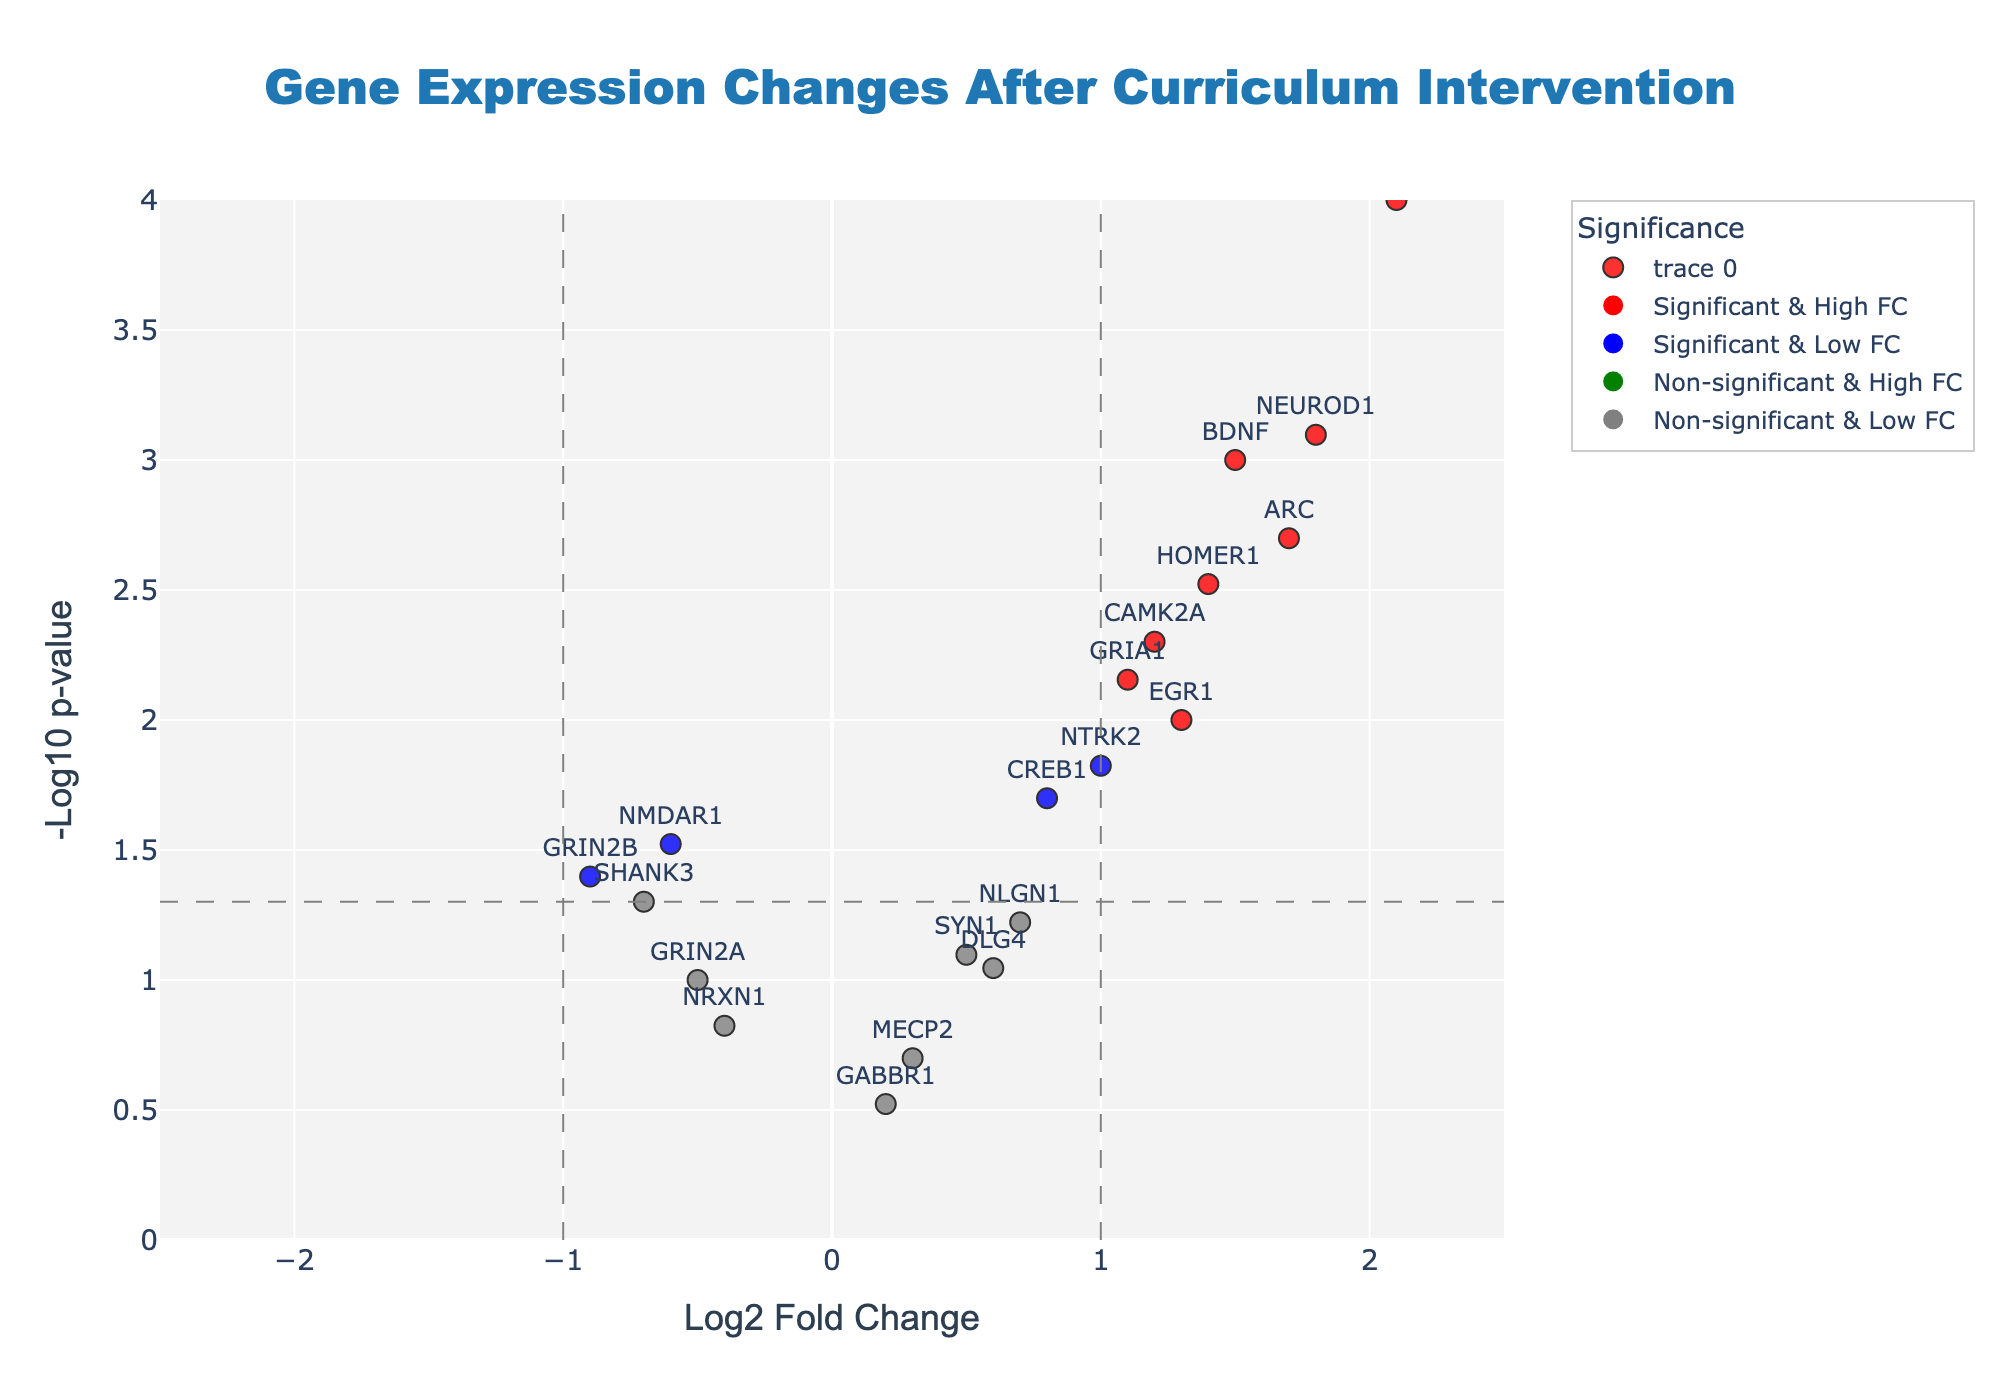What is the title of the plot? The title of the plot is displayed at the top center of the figure.
Answer: Gene Expression Changes After Curriculum Intervention What is the fold change threshold depicted by vertical lines? The vertical lines mark the fold change threshold on the x-axis. These lines are drawn at x = -1 and x = 1, indicating the threshold for significant log2 fold changes.
Answer: ±1 How many genes are considered both significant and have a high fold change? Genes that are significant and have a high fold change are marked in red on the plot. By counting the red dots, we can find the number of such genes.
Answer: 7 Which gene shows the highest log2 fold change and is it statistically significant? By observing the x-axis for the highest log2 fold change and checking if the respective point is colored red or blue (indicating significance), we can identify the gene.
Answer: FOS What is the significance level threshold, as indicated by the horizontal line? The horizontal line indicates the significance level threshold which is represented by -log10(p-value) on the y-axis. The threshold is -log10(0.05).
Answer: 1.3 Which gene has the lowest p-value and what is its -log10(p-value)? The lowest p-value corresponds to the highest point on the y-axis. The label for this highest point will give us the gene name, and the y-axis value will provide the -log10(p-value).
Answer: FOS, 4 How many genes are labeled as having non-significant and low fold change? Genes that are non-significant and have a low fold change are colored grey. Counting the number of grey dots will give us this count.
Answer: 8 Which gene has a log2 fold change greater than 1 but less than 2 and is also statistically significant? By focusing on the genes that fall between 1 and 2 on the x-axis and checking if their points are colored red or blue, we can identify this particular gene.
Answer: HOMER1 Compare the log2 fold change and significance level between BDNF and NTRK2. Which one has a higher fold change and which has a higher significance? To compare, locate BDNF and NTRK2 on the plot. Check their positions on the x-axis for fold change comparison and on the y-axis for significance level comparison. BDNF has a log2 fold change of 1.5 and NTRK2 has 1.0. BDNF’s -log10(p-value) is higher than NTRK2’s.
Answer: BDNF has higher fold change, BDNF is more significant What is the log2 fold change and p-value for the gene ARC? Locate the gene ARC on the plot and read off the values for the x-axis (log2 fold change) and the original p-value provided in hover information or data.
Answer: 1.7, 0.002 